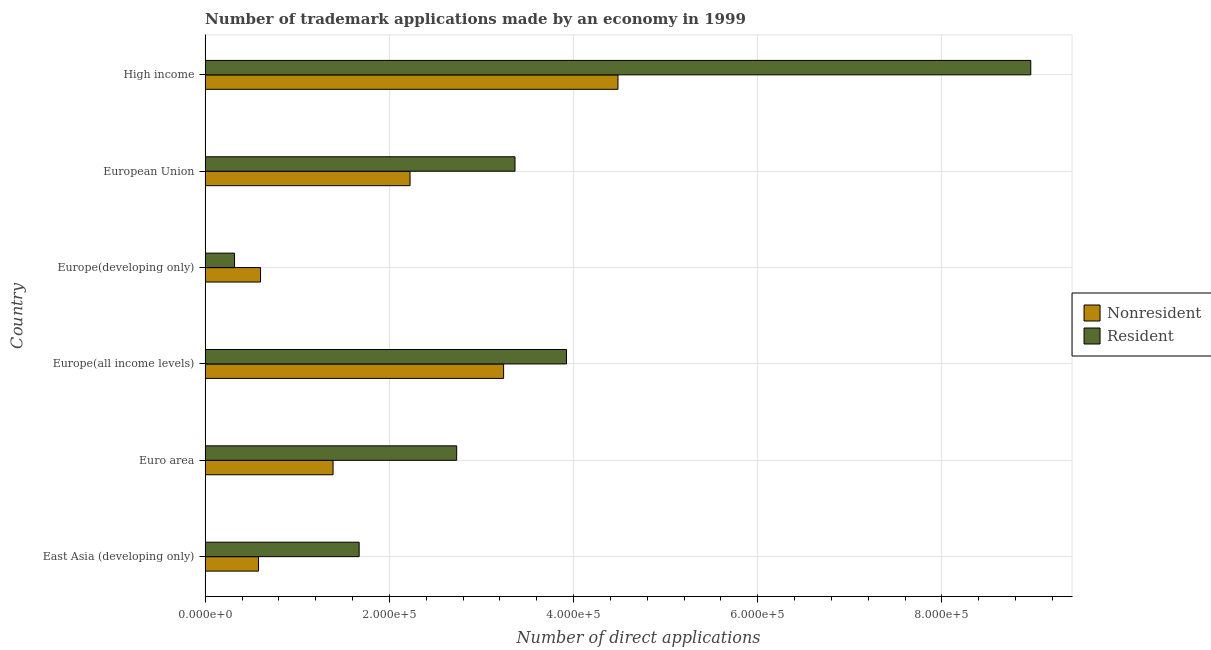How many different coloured bars are there?
Provide a succinct answer. 2. How many groups of bars are there?
Give a very brief answer. 6. Are the number of bars on each tick of the Y-axis equal?
Your answer should be very brief. Yes. How many bars are there on the 4th tick from the top?
Your answer should be very brief. 2. How many bars are there on the 1st tick from the bottom?
Make the answer very short. 2. What is the label of the 4th group of bars from the top?
Ensure brevity in your answer.  Europe(all income levels). What is the number of trademark applications made by residents in High income?
Ensure brevity in your answer.  8.96e+05. Across all countries, what is the maximum number of trademark applications made by non residents?
Provide a short and direct response. 4.48e+05. Across all countries, what is the minimum number of trademark applications made by residents?
Provide a succinct answer. 3.19e+04. In which country was the number of trademark applications made by non residents minimum?
Keep it short and to the point. East Asia (developing only). What is the total number of trademark applications made by non residents in the graph?
Your answer should be compact. 1.25e+06. What is the difference between the number of trademark applications made by residents in East Asia (developing only) and that in Europe(developing only)?
Make the answer very short. 1.35e+05. What is the difference between the number of trademark applications made by residents in Europe(all income levels) and the number of trademark applications made by non residents in European Union?
Offer a terse response. 1.70e+05. What is the average number of trademark applications made by non residents per country?
Make the answer very short. 2.09e+05. What is the difference between the number of trademark applications made by non residents and number of trademark applications made by residents in European Union?
Ensure brevity in your answer.  -1.14e+05. What is the ratio of the number of trademark applications made by non residents in Europe(developing only) to that in European Union?
Offer a very short reply. 0.27. Is the difference between the number of trademark applications made by non residents in East Asia (developing only) and Euro area greater than the difference between the number of trademark applications made by residents in East Asia (developing only) and Euro area?
Offer a terse response. Yes. What is the difference between the highest and the second highest number of trademark applications made by residents?
Ensure brevity in your answer.  5.04e+05. What is the difference between the highest and the lowest number of trademark applications made by residents?
Provide a succinct answer. 8.65e+05. In how many countries, is the number of trademark applications made by residents greater than the average number of trademark applications made by residents taken over all countries?
Ensure brevity in your answer.  2. Is the sum of the number of trademark applications made by non residents in Europe(all income levels) and High income greater than the maximum number of trademark applications made by residents across all countries?
Ensure brevity in your answer.  No. What does the 1st bar from the top in European Union represents?
Your answer should be very brief. Resident. What does the 2nd bar from the bottom in Europe(developing only) represents?
Give a very brief answer. Resident. Does the graph contain any zero values?
Ensure brevity in your answer.  No. Does the graph contain grids?
Your response must be concise. Yes. Where does the legend appear in the graph?
Provide a succinct answer. Center right. What is the title of the graph?
Provide a succinct answer. Number of trademark applications made by an economy in 1999. Does "Male labourers" appear as one of the legend labels in the graph?
Provide a short and direct response. No. What is the label or title of the X-axis?
Provide a short and direct response. Number of direct applications. What is the Number of direct applications in Nonresident in East Asia (developing only)?
Keep it short and to the point. 5.79e+04. What is the Number of direct applications of Resident in East Asia (developing only)?
Keep it short and to the point. 1.67e+05. What is the Number of direct applications in Nonresident in Euro area?
Your answer should be very brief. 1.39e+05. What is the Number of direct applications of Resident in Euro area?
Your answer should be compact. 2.73e+05. What is the Number of direct applications in Nonresident in Europe(all income levels)?
Keep it short and to the point. 3.24e+05. What is the Number of direct applications in Resident in Europe(all income levels)?
Your response must be concise. 3.92e+05. What is the Number of direct applications of Nonresident in Europe(developing only)?
Offer a very short reply. 6.01e+04. What is the Number of direct applications in Resident in Europe(developing only)?
Provide a short and direct response. 3.19e+04. What is the Number of direct applications in Nonresident in European Union?
Offer a very short reply. 2.22e+05. What is the Number of direct applications in Resident in European Union?
Your answer should be very brief. 3.36e+05. What is the Number of direct applications in Nonresident in High income?
Make the answer very short. 4.48e+05. What is the Number of direct applications in Resident in High income?
Provide a succinct answer. 8.96e+05. Across all countries, what is the maximum Number of direct applications of Nonresident?
Your answer should be very brief. 4.48e+05. Across all countries, what is the maximum Number of direct applications in Resident?
Provide a short and direct response. 8.96e+05. Across all countries, what is the minimum Number of direct applications of Nonresident?
Provide a succinct answer. 5.79e+04. Across all countries, what is the minimum Number of direct applications of Resident?
Offer a very short reply. 3.19e+04. What is the total Number of direct applications of Nonresident in the graph?
Offer a very short reply. 1.25e+06. What is the total Number of direct applications in Resident in the graph?
Offer a terse response. 2.10e+06. What is the difference between the Number of direct applications in Nonresident in East Asia (developing only) and that in Euro area?
Your response must be concise. -8.10e+04. What is the difference between the Number of direct applications in Resident in East Asia (developing only) and that in Euro area?
Offer a very short reply. -1.06e+05. What is the difference between the Number of direct applications in Nonresident in East Asia (developing only) and that in Europe(all income levels)?
Your response must be concise. -2.66e+05. What is the difference between the Number of direct applications of Resident in East Asia (developing only) and that in Europe(all income levels)?
Give a very brief answer. -2.25e+05. What is the difference between the Number of direct applications in Nonresident in East Asia (developing only) and that in Europe(developing only)?
Offer a terse response. -2209. What is the difference between the Number of direct applications of Resident in East Asia (developing only) and that in Europe(developing only)?
Provide a short and direct response. 1.35e+05. What is the difference between the Number of direct applications in Nonresident in East Asia (developing only) and that in European Union?
Your answer should be compact. -1.65e+05. What is the difference between the Number of direct applications in Resident in East Asia (developing only) and that in European Union?
Ensure brevity in your answer.  -1.69e+05. What is the difference between the Number of direct applications of Nonresident in East Asia (developing only) and that in High income?
Give a very brief answer. -3.90e+05. What is the difference between the Number of direct applications of Resident in East Asia (developing only) and that in High income?
Your answer should be very brief. -7.29e+05. What is the difference between the Number of direct applications of Nonresident in Euro area and that in Europe(all income levels)?
Keep it short and to the point. -1.85e+05. What is the difference between the Number of direct applications of Resident in Euro area and that in Europe(all income levels)?
Provide a succinct answer. -1.19e+05. What is the difference between the Number of direct applications of Nonresident in Euro area and that in Europe(developing only)?
Your answer should be compact. 7.88e+04. What is the difference between the Number of direct applications of Resident in Euro area and that in Europe(developing only)?
Give a very brief answer. 2.41e+05. What is the difference between the Number of direct applications in Nonresident in Euro area and that in European Union?
Your response must be concise. -8.36e+04. What is the difference between the Number of direct applications in Resident in Euro area and that in European Union?
Your answer should be compact. -6.33e+04. What is the difference between the Number of direct applications in Nonresident in Euro area and that in High income?
Your answer should be compact. -3.09e+05. What is the difference between the Number of direct applications of Resident in Euro area and that in High income?
Offer a very short reply. -6.23e+05. What is the difference between the Number of direct applications in Nonresident in Europe(all income levels) and that in Europe(developing only)?
Your answer should be very brief. 2.64e+05. What is the difference between the Number of direct applications of Resident in Europe(all income levels) and that in Europe(developing only)?
Your answer should be very brief. 3.60e+05. What is the difference between the Number of direct applications of Nonresident in Europe(all income levels) and that in European Union?
Provide a short and direct response. 1.02e+05. What is the difference between the Number of direct applications of Resident in Europe(all income levels) and that in European Union?
Ensure brevity in your answer.  5.59e+04. What is the difference between the Number of direct applications of Nonresident in Europe(all income levels) and that in High income?
Ensure brevity in your answer.  -1.24e+05. What is the difference between the Number of direct applications of Resident in Europe(all income levels) and that in High income?
Offer a terse response. -5.04e+05. What is the difference between the Number of direct applications of Nonresident in Europe(developing only) and that in European Union?
Make the answer very short. -1.62e+05. What is the difference between the Number of direct applications of Resident in Europe(developing only) and that in European Union?
Keep it short and to the point. -3.05e+05. What is the difference between the Number of direct applications in Nonresident in Europe(developing only) and that in High income?
Your answer should be very brief. -3.88e+05. What is the difference between the Number of direct applications in Resident in Europe(developing only) and that in High income?
Offer a very short reply. -8.65e+05. What is the difference between the Number of direct applications in Nonresident in European Union and that in High income?
Offer a very short reply. -2.26e+05. What is the difference between the Number of direct applications in Resident in European Union and that in High income?
Provide a succinct answer. -5.60e+05. What is the difference between the Number of direct applications in Nonresident in East Asia (developing only) and the Number of direct applications in Resident in Euro area?
Make the answer very short. -2.15e+05. What is the difference between the Number of direct applications of Nonresident in East Asia (developing only) and the Number of direct applications of Resident in Europe(all income levels)?
Ensure brevity in your answer.  -3.34e+05. What is the difference between the Number of direct applications in Nonresident in East Asia (developing only) and the Number of direct applications in Resident in Europe(developing only)?
Make the answer very short. 2.60e+04. What is the difference between the Number of direct applications of Nonresident in East Asia (developing only) and the Number of direct applications of Resident in European Union?
Keep it short and to the point. -2.79e+05. What is the difference between the Number of direct applications in Nonresident in East Asia (developing only) and the Number of direct applications in Resident in High income?
Provide a short and direct response. -8.39e+05. What is the difference between the Number of direct applications of Nonresident in Euro area and the Number of direct applications of Resident in Europe(all income levels)?
Ensure brevity in your answer.  -2.53e+05. What is the difference between the Number of direct applications in Nonresident in Euro area and the Number of direct applications in Resident in Europe(developing only)?
Provide a succinct answer. 1.07e+05. What is the difference between the Number of direct applications of Nonresident in Euro area and the Number of direct applications of Resident in European Union?
Your answer should be compact. -1.98e+05. What is the difference between the Number of direct applications of Nonresident in Euro area and the Number of direct applications of Resident in High income?
Provide a succinct answer. -7.58e+05. What is the difference between the Number of direct applications in Nonresident in Europe(all income levels) and the Number of direct applications in Resident in Europe(developing only)?
Give a very brief answer. 2.92e+05. What is the difference between the Number of direct applications of Nonresident in Europe(all income levels) and the Number of direct applications of Resident in European Union?
Provide a succinct answer. -1.24e+04. What is the difference between the Number of direct applications in Nonresident in Europe(all income levels) and the Number of direct applications in Resident in High income?
Provide a short and direct response. -5.72e+05. What is the difference between the Number of direct applications of Nonresident in Europe(developing only) and the Number of direct applications of Resident in European Union?
Offer a very short reply. -2.76e+05. What is the difference between the Number of direct applications in Nonresident in Europe(developing only) and the Number of direct applications in Resident in High income?
Keep it short and to the point. -8.36e+05. What is the difference between the Number of direct applications of Nonresident in European Union and the Number of direct applications of Resident in High income?
Your answer should be compact. -6.74e+05. What is the average Number of direct applications in Nonresident per country?
Provide a short and direct response. 2.09e+05. What is the average Number of direct applications in Resident per country?
Your response must be concise. 3.50e+05. What is the difference between the Number of direct applications in Nonresident and Number of direct applications in Resident in East Asia (developing only)?
Your response must be concise. -1.09e+05. What is the difference between the Number of direct applications in Nonresident and Number of direct applications in Resident in Euro area?
Provide a succinct answer. -1.34e+05. What is the difference between the Number of direct applications of Nonresident and Number of direct applications of Resident in Europe(all income levels)?
Your response must be concise. -6.83e+04. What is the difference between the Number of direct applications in Nonresident and Number of direct applications in Resident in Europe(developing only)?
Offer a very short reply. 2.82e+04. What is the difference between the Number of direct applications in Nonresident and Number of direct applications in Resident in European Union?
Ensure brevity in your answer.  -1.14e+05. What is the difference between the Number of direct applications in Nonresident and Number of direct applications in Resident in High income?
Give a very brief answer. -4.48e+05. What is the ratio of the Number of direct applications in Nonresident in East Asia (developing only) to that in Euro area?
Make the answer very short. 0.42. What is the ratio of the Number of direct applications of Resident in East Asia (developing only) to that in Euro area?
Your answer should be compact. 0.61. What is the ratio of the Number of direct applications in Nonresident in East Asia (developing only) to that in Europe(all income levels)?
Offer a terse response. 0.18. What is the ratio of the Number of direct applications in Resident in East Asia (developing only) to that in Europe(all income levels)?
Your response must be concise. 0.43. What is the ratio of the Number of direct applications in Nonresident in East Asia (developing only) to that in Europe(developing only)?
Your answer should be compact. 0.96. What is the ratio of the Number of direct applications of Resident in East Asia (developing only) to that in Europe(developing only)?
Offer a very short reply. 5.25. What is the ratio of the Number of direct applications in Nonresident in East Asia (developing only) to that in European Union?
Your answer should be compact. 0.26. What is the ratio of the Number of direct applications of Resident in East Asia (developing only) to that in European Union?
Your answer should be compact. 0.5. What is the ratio of the Number of direct applications in Nonresident in East Asia (developing only) to that in High income?
Provide a short and direct response. 0.13. What is the ratio of the Number of direct applications in Resident in East Asia (developing only) to that in High income?
Your response must be concise. 0.19. What is the ratio of the Number of direct applications of Nonresident in Euro area to that in Europe(all income levels)?
Keep it short and to the point. 0.43. What is the ratio of the Number of direct applications in Resident in Euro area to that in Europe(all income levels)?
Offer a very short reply. 0.7. What is the ratio of the Number of direct applications of Nonresident in Euro area to that in Europe(developing only)?
Your response must be concise. 2.31. What is the ratio of the Number of direct applications of Resident in Euro area to that in Europe(developing only)?
Your answer should be compact. 8.57. What is the ratio of the Number of direct applications in Nonresident in Euro area to that in European Union?
Your answer should be compact. 0.62. What is the ratio of the Number of direct applications in Resident in Euro area to that in European Union?
Your answer should be very brief. 0.81. What is the ratio of the Number of direct applications in Nonresident in Euro area to that in High income?
Your answer should be very brief. 0.31. What is the ratio of the Number of direct applications of Resident in Euro area to that in High income?
Your response must be concise. 0.3. What is the ratio of the Number of direct applications in Nonresident in Europe(all income levels) to that in Europe(developing only)?
Provide a succinct answer. 5.39. What is the ratio of the Number of direct applications in Resident in Europe(all income levels) to that in Europe(developing only)?
Offer a very short reply. 12.31. What is the ratio of the Number of direct applications of Nonresident in Europe(all income levels) to that in European Union?
Provide a succinct answer. 1.46. What is the ratio of the Number of direct applications in Resident in Europe(all income levels) to that in European Union?
Your answer should be very brief. 1.17. What is the ratio of the Number of direct applications of Nonresident in Europe(all income levels) to that in High income?
Your answer should be compact. 0.72. What is the ratio of the Number of direct applications of Resident in Europe(all income levels) to that in High income?
Provide a succinct answer. 0.44. What is the ratio of the Number of direct applications of Nonresident in Europe(developing only) to that in European Union?
Keep it short and to the point. 0.27. What is the ratio of the Number of direct applications in Resident in Europe(developing only) to that in European Union?
Keep it short and to the point. 0.09. What is the ratio of the Number of direct applications in Nonresident in Europe(developing only) to that in High income?
Provide a short and direct response. 0.13. What is the ratio of the Number of direct applications in Resident in Europe(developing only) to that in High income?
Your response must be concise. 0.04. What is the ratio of the Number of direct applications in Nonresident in European Union to that in High income?
Your answer should be compact. 0.5. What is the ratio of the Number of direct applications of Resident in European Union to that in High income?
Provide a short and direct response. 0.38. What is the difference between the highest and the second highest Number of direct applications of Nonresident?
Offer a very short reply. 1.24e+05. What is the difference between the highest and the second highest Number of direct applications of Resident?
Give a very brief answer. 5.04e+05. What is the difference between the highest and the lowest Number of direct applications in Nonresident?
Offer a very short reply. 3.90e+05. What is the difference between the highest and the lowest Number of direct applications in Resident?
Your answer should be compact. 8.65e+05. 